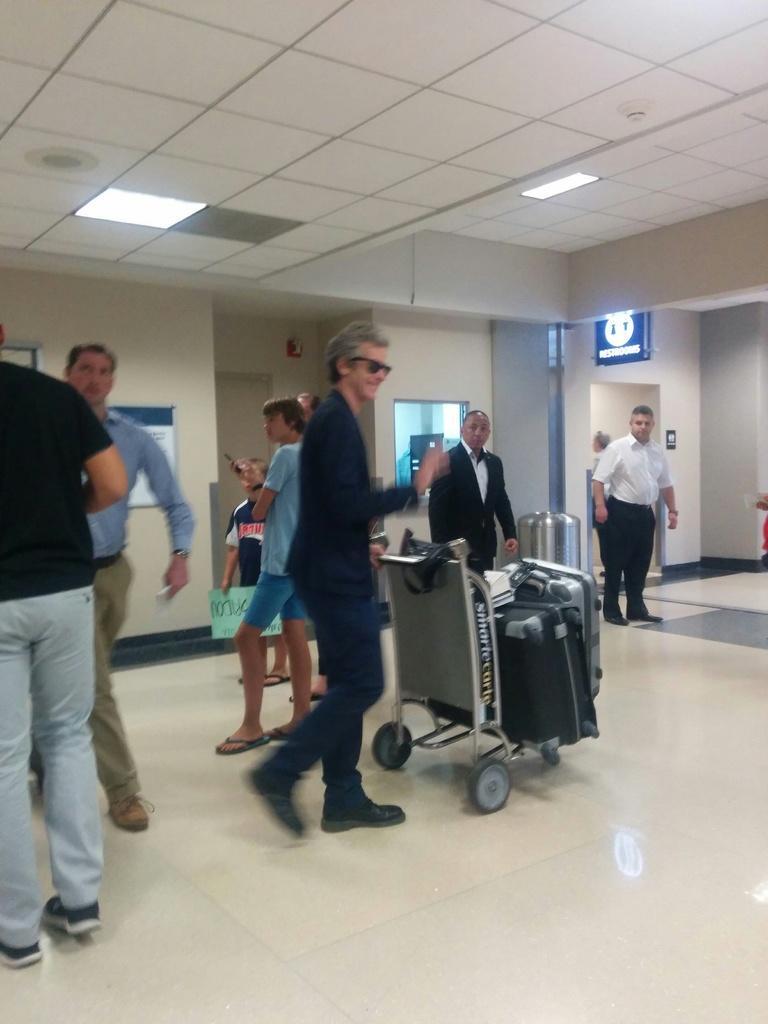Could you give a brief overview of what you see in this image? In this image I can see few people around. In front the person is holding trolley. We can see few suitcase in trolley. Back Side I can see signboard and window. The wall is in cream color. Top I can see lights. 